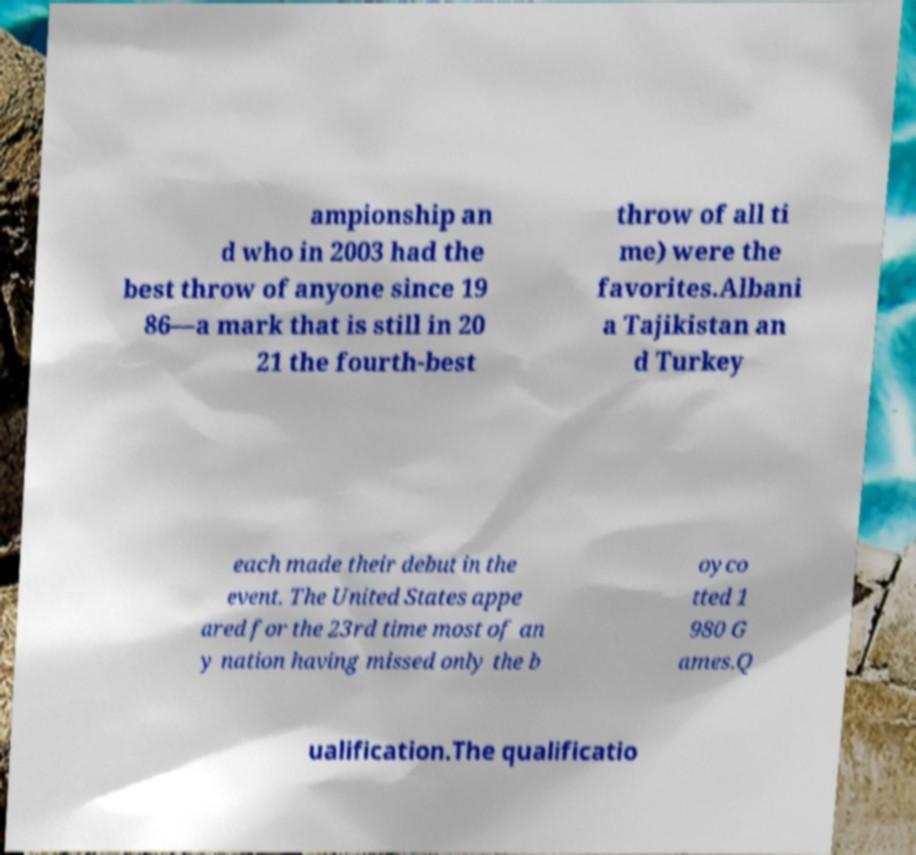I need the written content from this picture converted into text. Can you do that? ampionship an d who in 2003 had the best throw of anyone since 19 86—a mark that is still in 20 21 the fourth-best throw of all ti me) were the favorites.Albani a Tajikistan an d Turkey each made their debut in the event. The United States appe ared for the 23rd time most of an y nation having missed only the b oyco tted 1 980 G ames.Q ualification.The qualificatio 